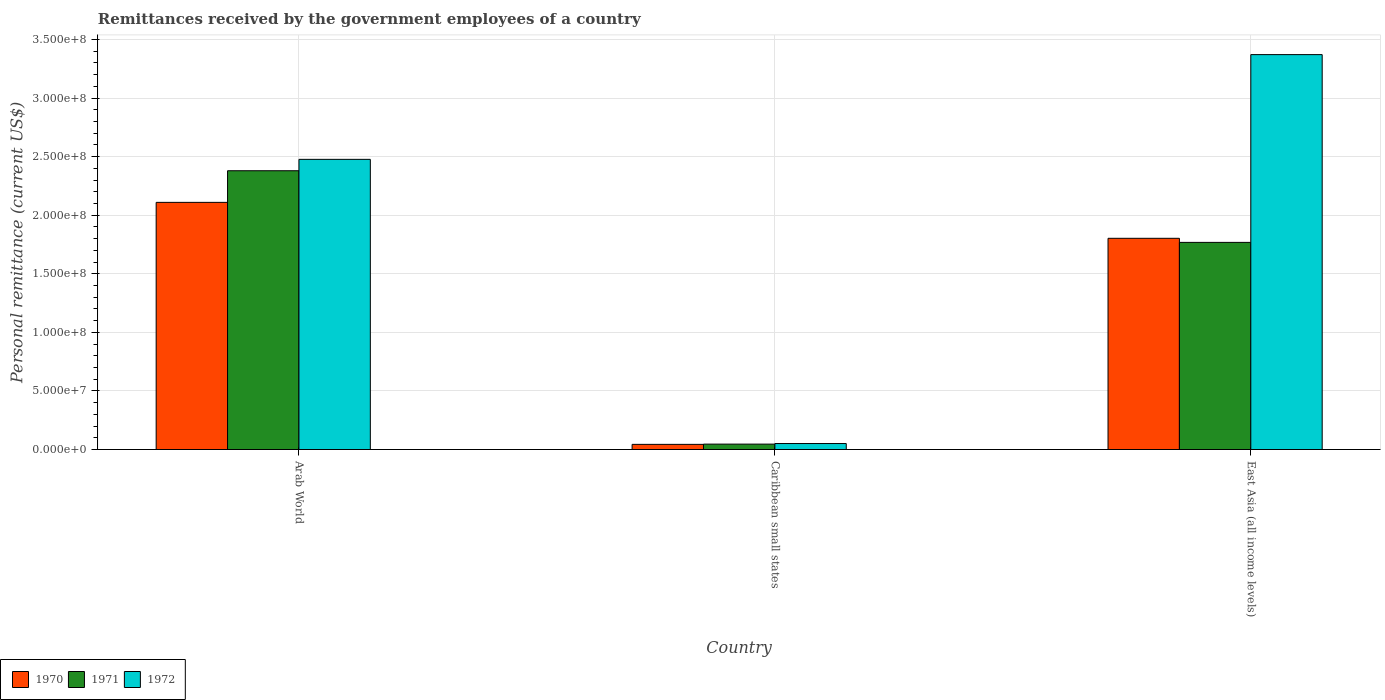How many different coloured bars are there?
Offer a terse response. 3. Are the number of bars per tick equal to the number of legend labels?
Your response must be concise. Yes. How many bars are there on the 3rd tick from the left?
Give a very brief answer. 3. How many bars are there on the 3rd tick from the right?
Provide a succinct answer. 3. What is the label of the 2nd group of bars from the left?
Your answer should be compact. Caribbean small states. In how many cases, is the number of bars for a given country not equal to the number of legend labels?
Keep it short and to the point. 0. What is the remittances received by the government employees in 1970 in East Asia (all income levels)?
Keep it short and to the point. 1.80e+08. Across all countries, what is the maximum remittances received by the government employees in 1971?
Offer a terse response. 2.38e+08. Across all countries, what is the minimum remittances received by the government employees in 1971?
Your answer should be very brief. 4.61e+06. In which country was the remittances received by the government employees in 1972 maximum?
Keep it short and to the point. East Asia (all income levels). In which country was the remittances received by the government employees in 1971 minimum?
Your response must be concise. Caribbean small states. What is the total remittances received by the government employees in 1970 in the graph?
Your answer should be very brief. 3.96e+08. What is the difference between the remittances received by the government employees in 1970 in Caribbean small states and that in East Asia (all income levels)?
Provide a short and direct response. -1.76e+08. What is the difference between the remittances received by the government employees in 1972 in Arab World and the remittances received by the government employees in 1970 in Caribbean small states?
Offer a very short reply. 2.43e+08. What is the average remittances received by the government employees in 1971 per country?
Provide a short and direct response. 1.40e+08. What is the difference between the remittances received by the government employees of/in 1971 and remittances received by the government employees of/in 1970 in Arab World?
Offer a terse response. 2.70e+07. What is the ratio of the remittances received by the government employees in 1971 in Arab World to that in East Asia (all income levels)?
Provide a short and direct response. 1.35. What is the difference between the highest and the second highest remittances received by the government employees in 1970?
Provide a short and direct response. 2.07e+08. What is the difference between the highest and the lowest remittances received by the government employees in 1972?
Make the answer very short. 3.32e+08. In how many countries, is the remittances received by the government employees in 1971 greater than the average remittances received by the government employees in 1971 taken over all countries?
Provide a short and direct response. 2. Is the sum of the remittances received by the government employees in 1971 in Caribbean small states and East Asia (all income levels) greater than the maximum remittances received by the government employees in 1972 across all countries?
Your response must be concise. No. What does the 1st bar from the right in East Asia (all income levels) represents?
Your answer should be very brief. 1972. Is it the case that in every country, the sum of the remittances received by the government employees in 1971 and remittances received by the government employees in 1970 is greater than the remittances received by the government employees in 1972?
Your answer should be compact. Yes. How many bars are there?
Offer a terse response. 9. Are all the bars in the graph horizontal?
Offer a terse response. No. What is the difference between two consecutive major ticks on the Y-axis?
Make the answer very short. 5.00e+07. Are the values on the major ticks of Y-axis written in scientific E-notation?
Provide a succinct answer. Yes. Does the graph contain grids?
Your answer should be very brief. Yes. How are the legend labels stacked?
Provide a short and direct response. Horizontal. What is the title of the graph?
Give a very brief answer. Remittances received by the government employees of a country. What is the label or title of the X-axis?
Offer a very short reply. Country. What is the label or title of the Y-axis?
Provide a succinct answer. Personal remittance (current US$). What is the Personal remittance (current US$) in 1970 in Arab World?
Your answer should be compact. 2.11e+08. What is the Personal remittance (current US$) of 1971 in Arab World?
Make the answer very short. 2.38e+08. What is the Personal remittance (current US$) of 1972 in Arab World?
Offer a very short reply. 2.48e+08. What is the Personal remittance (current US$) of 1970 in Caribbean small states?
Provide a short and direct response. 4.40e+06. What is the Personal remittance (current US$) in 1971 in Caribbean small states?
Your response must be concise. 4.61e+06. What is the Personal remittance (current US$) of 1972 in Caribbean small states?
Your response must be concise. 5.10e+06. What is the Personal remittance (current US$) of 1970 in East Asia (all income levels)?
Offer a terse response. 1.80e+08. What is the Personal remittance (current US$) in 1971 in East Asia (all income levels)?
Make the answer very short. 1.77e+08. What is the Personal remittance (current US$) in 1972 in East Asia (all income levels)?
Offer a terse response. 3.37e+08. Across all countries, what is the maximum Personal remittance (current US$) of 1970?
Provide a succinct answer. 2.11e+08. Across all countries, what is the maximum Personal remittance (current US$) of 1971?
Keep it short and to the point. 2.38e+08. Across all countries, what is the maximum Personal remittance (current US$) of 1972?
Make the answer very short. 3.37e+08. Across all countries, what is the minimum Personal remittance (current US$) of 1970?
Your answer should be compact. 4.40e+06. Across all countries, what is the minimum Personal remittance (current US$) of 1971?
Offer a very short reply. 4.61e+06. Across all countries, what is the minimum Personal remittance (current US$) in 1972?
Provide a short and direct response. 5.10e+06. What is the total Personal remittance (current US$) of 1970 in the graph?
Offer a very short reply. 3.96e+08. What is the total Personal remittance (current US$) of 1971 in the graph?
Your answer should be compact. 4.19e+08. What is the total Personal remittance (current US$) in 1972 in the graph?
Give a very brief answer. 5.90e+08. What is the difference between the Personal remittance (current US$) in 1970 in Arab World and that in Caribbean small states?
Your response must be concise. 2.07e+08. What is the difference between the Personal remittance (current US$) in 1971 in Arab World and that in Caribbean small states?
Offer a very short reply. 2.33e+08. What is the difference between the Personal remittance (current US$) of 1972 in Arab World and that in Caribbean small states?
Provide a short and direct response. 2.43e+08. What is the difference between the Personal remittance (current US$) of 1970 in Arab World and that in East Asia (all income levels)?
Your response must be concise. 3.07e+07. What is the difference between the Personal remittance (current US$) in 1971 in Arab World and that in East Asia (all income levels)?
Your answer should be compact. 6.12e+07. What is the difference between the Personal remittance (current US$) of 1972 in Arab World and that in East Asia (all income levels)?
Give a very brief answer. -8.94e+07. What is the difference between the Personal remittance (current US$) of 1970 in Caribbean small states and that in East Asia (all income levels)?
Your answer should be very brief. -1.76e+08. What is the difference between the Personal remittance (current US$) in 1971 in Caribbean small states and that in East Asia (all income levels)?
Your answer should be compact. -1.72e+08. What is the difference between the Personal remittance (current US$) in 1972 in Caribbean small states and that in East Asia (all income levels)?
Your answer should be compact. -3.32e+08. What is the difference between the Personal remittance (current US$) in 1970 in Arab World and the Personal remittance (current US$) in 1971 in Caribbean small states?
Offer a very short reply. 2.06e+08. What is the difference between the Personal remittance (current US$) in 1970 in Arab World and the Personal remittance (current US$) in 1972 in Caribbean small states?
Give a very brief answer. 2.06e+08. What is the difference between the Personal remittance (current US$) in 1971 in Arab World and the Personal remittance (current US$) in 1972 in Caribbean small states?
Ensure brevity in your answer.  2.33e+08. What is the difference between the Personal remittance (current US$) in 1970 in Arab World and the Personal remittance (current US$) in 1971 in East Asia (all income levels)?
Your answer should be very brief. 3.42e+07. What is the difference between the Personal remittance (current US$) of 1970 in Arab World and the Personal remittance (current US$) of 1972 in East Asia (all income levels)?
Your response must be concise. -1.26e+08. What is the difference between the Personal remittance (current US$) in 1971 in Arab World and the Personal remittance (current US$) in 1972 in East Asia (all income levels)?
Your answer should be very brief. -9.91e+07. What is the difference between the Personal remittance (current US$) of 1970 in Caribbean small states and the Personal remittance (current US$) of 1971 in East Asia (all income levels)?
Your answer should be very brief. -1.72e+08. What is the difference between the Personal remittance (current US$) in 1970 in Caribbean small states and the Personal remittance (current US$) in 1972 in East Asia (all income levels)?
Give a very brief answer. -3.33e+08. What is the difference between the Personal remittance (current US$) of 1971 in Caribbean small states and the Personal remittance (current US$) of 1972 in East Asia (all income levels)?
Make the answer very short. -3.33e+08. What is the average Personal remittance (current US$) in 1970 per country?
Keep it short and to the point. 1.32e+08. What is the average Personal remittance (current US$) of 1971 per country?
Your answer should be very brief. 1.40e+08. What is the average Personal remittance (current US$) in 1972 per country?
Offer a terse response. 1.97e+08. What is the difference between the Personal remittance (current US$) in 1970 and Personal remittance (current US$) in 1971 in Arab World?
Provide a short and direct response. -2.70e+07. What is the difference between the Personal remittance (current US$) in 1970 and Personal remittance (current US$) in 1972 in Arab World?
Give a very brief answer. -3.67e+07. What is the difference between the Personal remittance (current US$) in 1971 and Personal remittance (current US$) in 1972 in Arab World?
Offer a terse response. -9.72e+06. What is the difference between the Personal remittance (current US$) of 1970 and Personal remittance (current US$) of 1971 in Caribbean small states?
Offer a very short reply. -2.08e+05. What is the difference between the Personal remittance (current US$) in 1970 and Personal remittance (current US$) in 1972 in Caribbean small states?
Make the answer very short. -7.01e+05. What is the difference between the Personal remittance (current US$) of 1971 and Personal remittance (current US$) of 1972 in Caribbean small states?
Your answer should be compact. -4.93e+05. What is the difference between the Personal remittance (current US$) in 1970 and Personal remittance (current US$) in 1971 in East Asia (all income levels)?
Offer a very short reply. 3.48e+06. What is the difference between the Personal remittance (current US$) of 1970 and Personal remittance (current US$) of 1972 in East Asia (all income levels)?
Offer a terse response. -1.57e+08. What is the difference between the Personal remittance (current US$) in 1971 and Personal remittance (current US$) in 1972 in East Asia (all income levels)?
Your response must be concise. -1.60e+08. What is the ratio of the Personal remittance (current US$) of 1970 in Arab World to that in Caribbean small states?
Your response must be concise. 47.95. What is the ratio of the Personal remittance (current US$) of 1971 in Arab World to that in Caribbean small states?
Make the answer very short. 51.65. What is the ratio of the Personal remittance (current US$) in 1972 in Arab World to that in Caribbean small states?
Ensure brevity in your answer.  48.57. What is the ratio of the Personal remittance (current US$) of 1970 in Arab World to that in East Asia (all income levels)?
Provide a succinct answer. 1.17. What is the ratio of the Personal remittance (current US$) of 1971 in Arab World to that in East Asia (all income levels)?
Keep it short and to the point. 1.35. What is the ratio of the Personal remittance (current US$) in 1972 in Arab World to that in East Asia (all income levels)?
Ensure brevity in your answer.  0.73. What is the ratio of the Personal remittance (current US$) in 1970 in Caribbean small states to that in East Asia (all income levels)?
Your answer should be compact. 0.02. What is the ratio of the Personal remittance (current US$) of 1971 in Caribbean small states to that in East Asia (all income levels)?
Offer a very short reply. 0.03. What is the ratio of the Personal remittance (current US$) in 1972 in Caribbean small states to that in East Asia (all income levels)?
Offer a terse response. 0.02. What is the difference between the highest and the second highest Personal remittance (current US$) of 1970?
Your answer should be very brief. 3.07e+07. What is the difference between the highest and the second highest Personal remittance (current US$) of 1971?
Provide a short and direct response. 6.12e+07. What is the difference between the highest and the second highest Personal remittance (current US$) of 1972?
Give a very brief answer. 8.94e+07. What is the difference between the highest and the lowest Personal remittance (current US$) in 1970?
Provide a succinct answer. 2.07e+08. What is the difference between the highest and the lowest Personal remittance (current US$) of 1971?
Give a very brief answer. 2.33e+08. What is the difference between the highest and the lowest Personal remittance (current US$) of 1972?
Provide a succinct answer. 3.32e+08. 